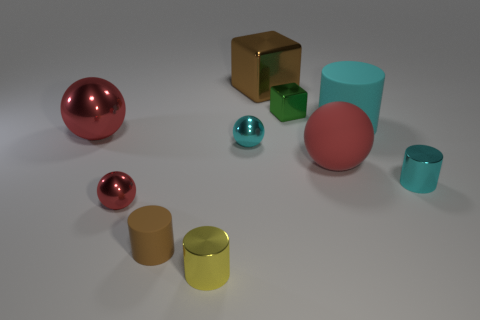There is a metallic thing that is the same color as the small rubber thing; what is its size?
Offer a terse response. Large. What shape is the large object that is the same color as the small rubber cylinder?
Give a very brief answer. Cube. What material is the yellow cylinder?
Offer a very short reply. Metal. Is the material of the brown cube the same as the brown object that is in front of the big red matte thing?
Give a very brief answer. No. Is there anything else that has the same color as the large rubber ball?
Provide a succinct answer. Yes. Are there any tiny shiny objects that are behind the red sphere behind the cyan metal object that is left of the small cyan metal cylinder?
Make the answer very short. Yes. What color is the big cylinder?
Offer a terse response. Cyan. Are there any yellow cylinders behind the brown cylinder?
Your response must be concise. No. Does the small yellow thing have the same shape as the tiny shiny thing that is right of the large cyan cylinder?
Make the answer very short. Yes. What number of other objects are the same material as the big brown thing?
Provide a short and direct response. 6. 